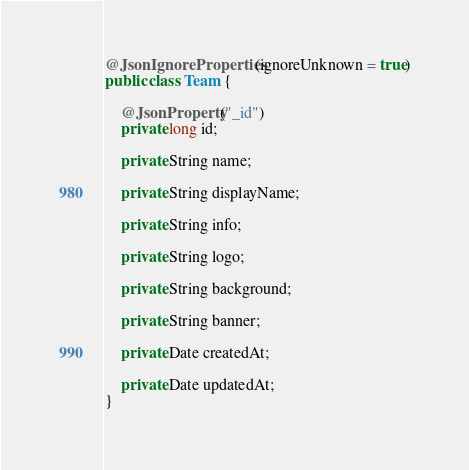<code> <loc_0><loc_0><loc_500><loc_500><_Java_>@JsonIgnoreProperties(ignoreUnknown = true)
public class Team {

	@JsonProperty("_id")
	private long id;

	private String name;

	private String displayName;

	private String info;

	private String logo;

	private String background;

	private String banner;

	private Date createdAt;

	private Date updatedAt;
}
</code> 